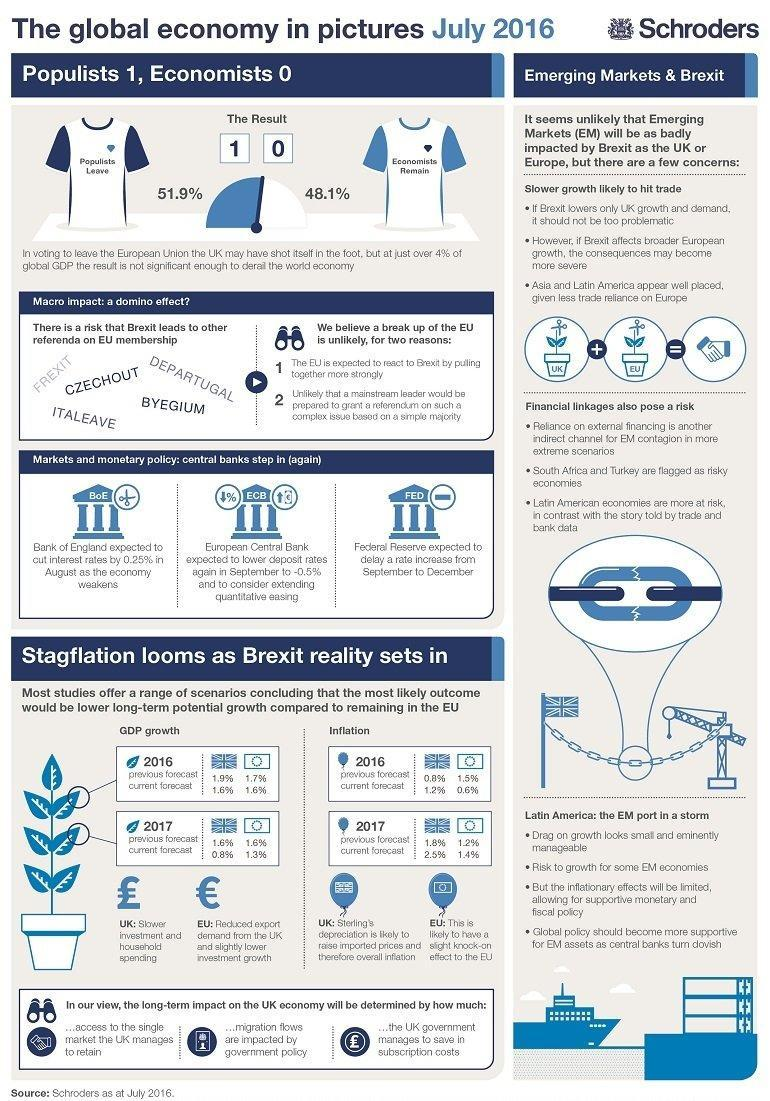What was voted by 51.9% people in UK?
Answer the question with a short phrase. to leave the European Union Whi is expected to delay a rate increase from September to December? Federal Reserve Who is expected to lower deposit rates? European Central Bank What is the current forecast for GDP growth in 2016 for UK? 1.6% How many voted that UK should not leave EU? 48.1% Which continents rely lesser on trade with Europe? Asia and Latin America Who is expected to cut interest rates in August as economy weakens? Bank of England What is the current forecast for inflation in 2017 for the rest of EU? 1.4% 